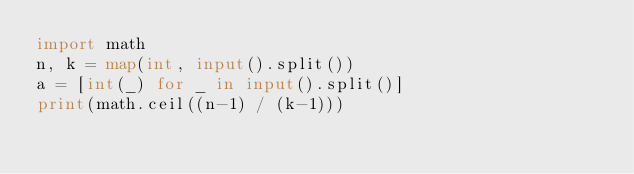Convert code to text. <code><loc_0><loc_0><loc_500><loc_500><_Python_>import math
n, k = map(int, input().split())
a = [int(_) for _ in input().split()]
print(math.ceil((n-1) / (k-1)))</code> 